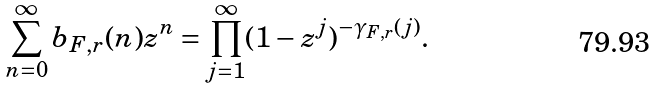Convert formula to latex. <formula><loc_0><loc_0><loc_500><loc_500>\sum _ { n = 0 } ^ { \infty } b _ { F , r } ( n ) z ^ { n } = \prod _ { j = 1 } ^ { \infty } ( 1 - z ^ { j } ) ^ { - \gamma _ { F , r } ( j ) } .</formula> 